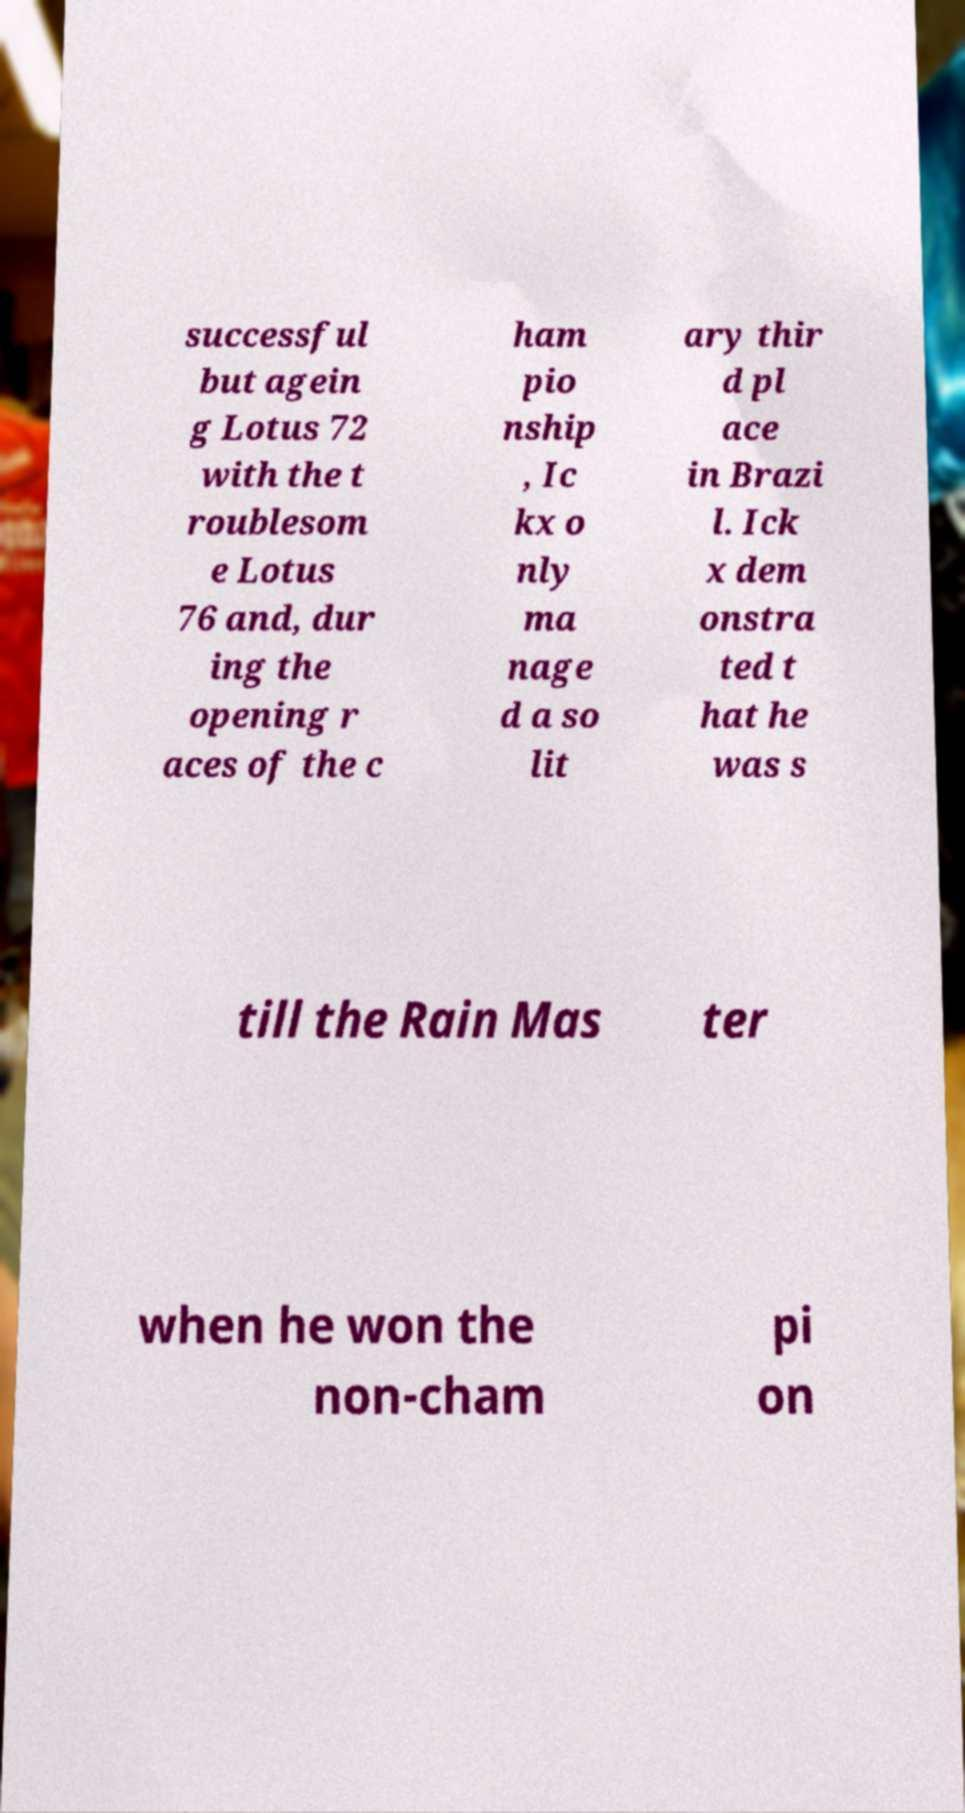Can you accurately transcribe the text from the provided image for me? successful but agein g Lotus 72 with the t roublesom e Lotus 76 and, dur ing the opening r aces of the c ham pio nship , Ic kx o nly ma nage d a so lit ary thir d pl ace in Brazi l. Ick x dem onstra ted t hat he was s till the Rain Mas ter when he won the non-cham pi on 